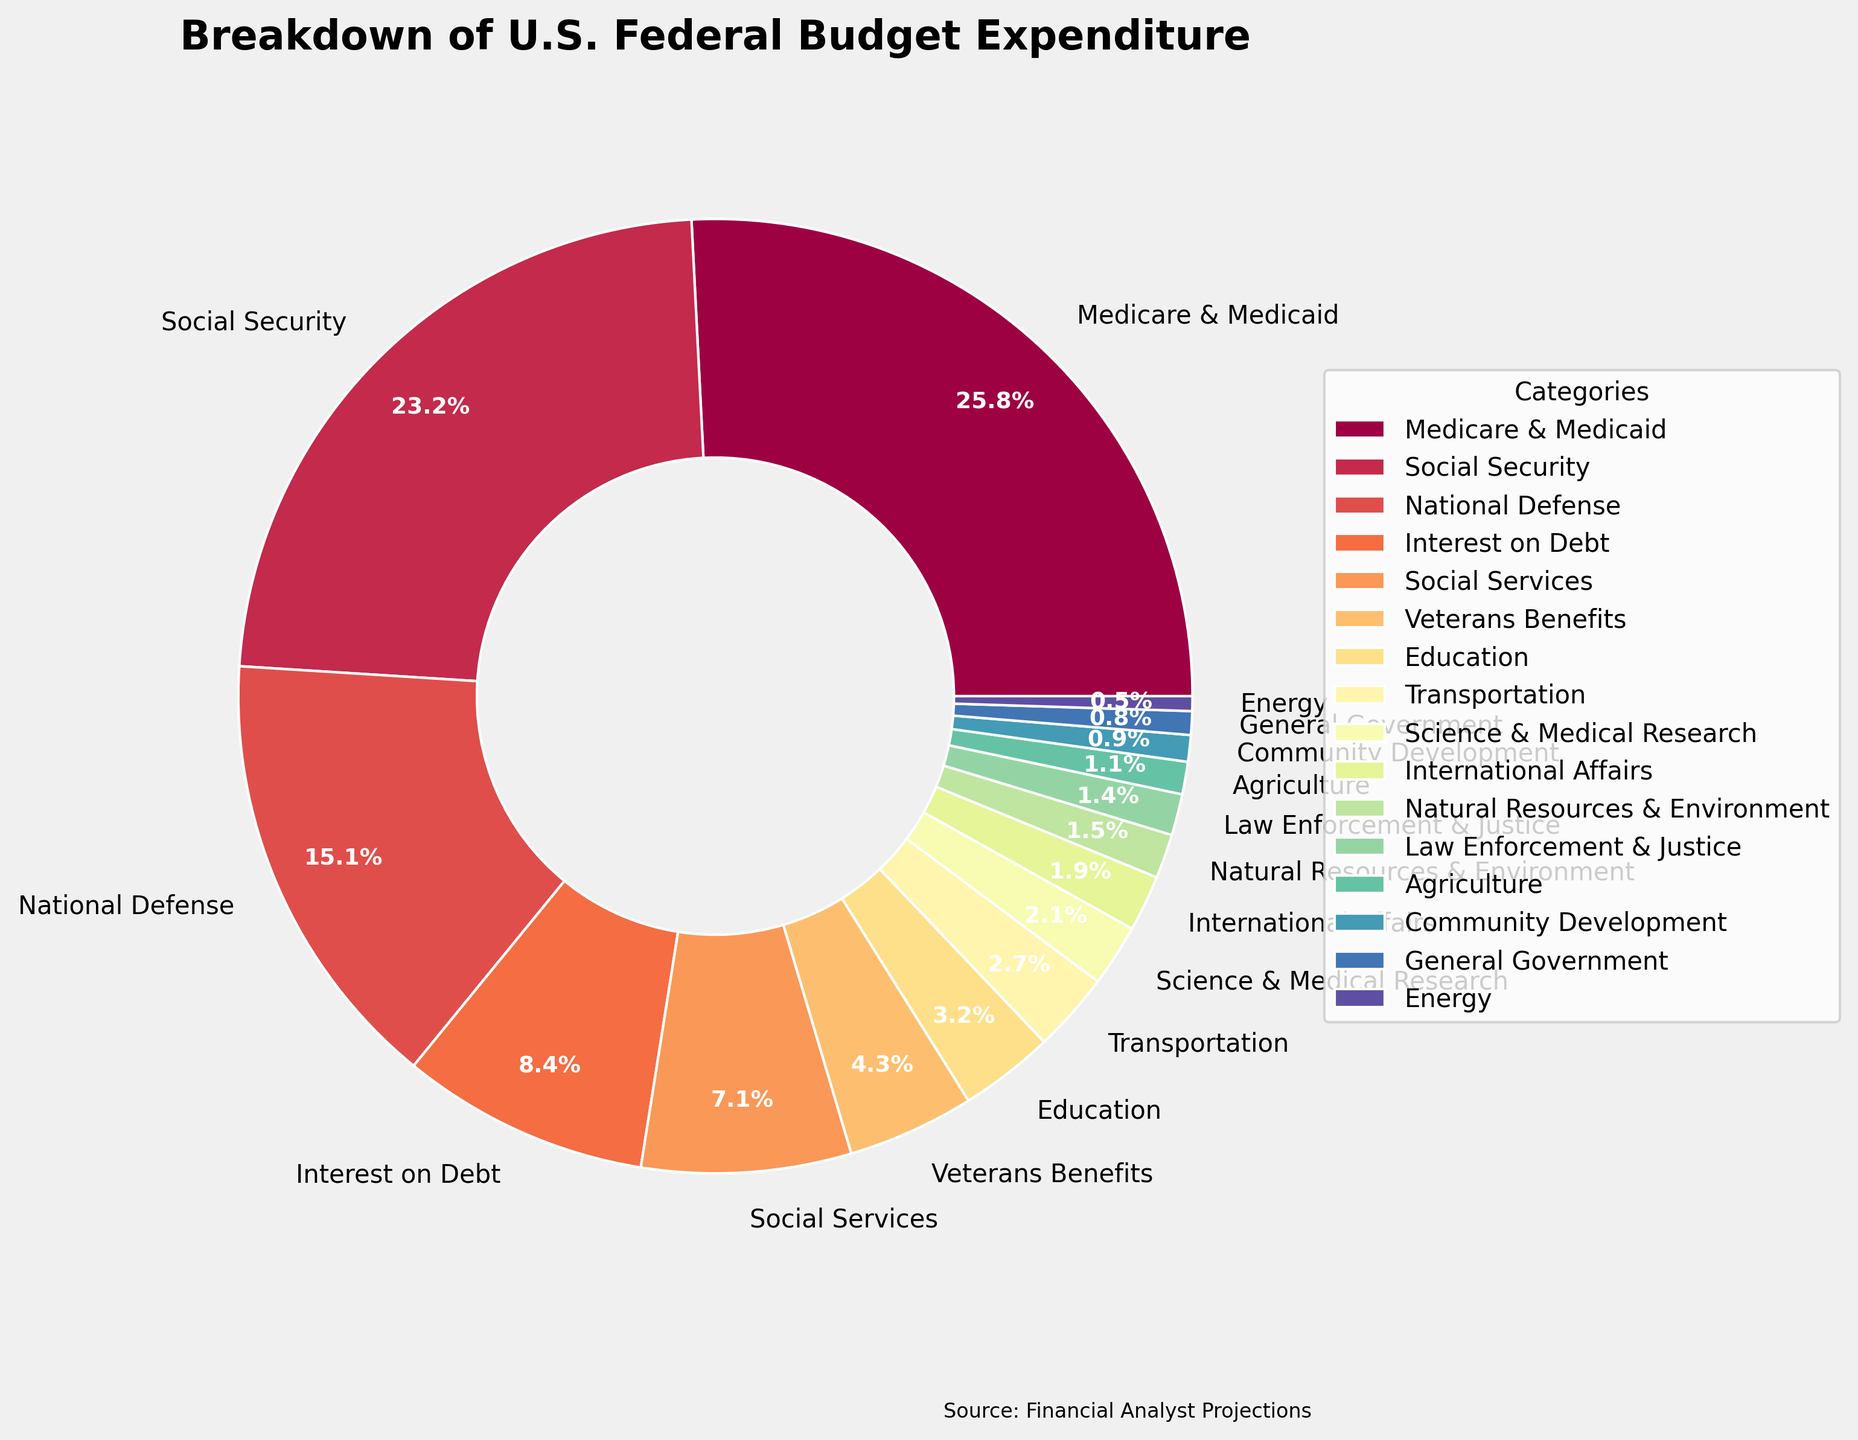What's the largest category of expenditure in the U.S. federal budget? By looking at the figure, we can see that the largest sector with the highest percentage value is "Medicare & Medicaid" at 25.8%.
Answer: Medicare & Medicaid What's the smallest category of expenditure in the U.S. federal budget? By looking at the chart, the smallest category with the lowest percentage is "Energy" at 0.5%.
Answer: Energy What's the total percentage spent on Social Security and National Defense combined? From the figure, Social Security is 23.2% and National Defense is 15.1%. Adding these together gives 23.2% + 15.1% = 38.3%.
Answer: 38.3% What's the percentage point difference between spending on Medicare & Medicaid and National Defense? The chart shows that Medicare & Medicaid is 25.8% and National Defense is 15.1%. The difference is 25.8% - 15.1% = 10.7%.
Answer: 10.7% Which category spends more, Education or Veterans Benefits, and by how much? From the chart, Education accounts for 3.2% and Veterans Benefits account for 4.3%. The difference is 4.3% - 3.2% = 1.1%. Hence, Veterans Benefits spend more by 1.1%.
Answer: Veterans Benefits, 1.1% What is the combined percentage spent on Science & Medical Research and International Affairs? The pie chart shows Science & Medical Research at 2.1% and International Affairs at 1.9%. Their combined spending is 2.1% + 1.9% = 4.0%.
Answer: 4.0% Is the spending on Social Services higher or lower than that of National Defense, and by how much? Social Services account for 7.1% and National Defense for 15.1%. The difference is 15.1% - 7.1% = 8.0%, thus National Defense spending is higher by 8.0%.
Answer: Higher, 8.0% What is the total percentage spent on the three smallest categories combined? The three smallest categories from the chart are General Government (0.8%), Energy (0.5%), and Community Development (0.9%). Adding these together, we get 0.8% + 0.5% + 0.9% = 2.2%.
Answer: 2.2% Which two categories, if combined, make up the largest portion of the budget? By visually comparing combinations, the largest categories are Medicare & Medicaid (25.8%) and Social Security (23.2%). Their combined total is 25.8% + 23.2% = 49.0%.
Answer: Medicare & Medicaid and Social Security What is the percentage spent on Interest on Debt relative to the total percentage spent on Education and Transportation combined? Interest on Debt is 8.4%. Education and Transportation together are 3.2% + 2.7% = 5.9%. The relative percentage is calculated as (8.4% / 5.9%) * 100 ≈ 142.37%.
Answer: 142.37% 